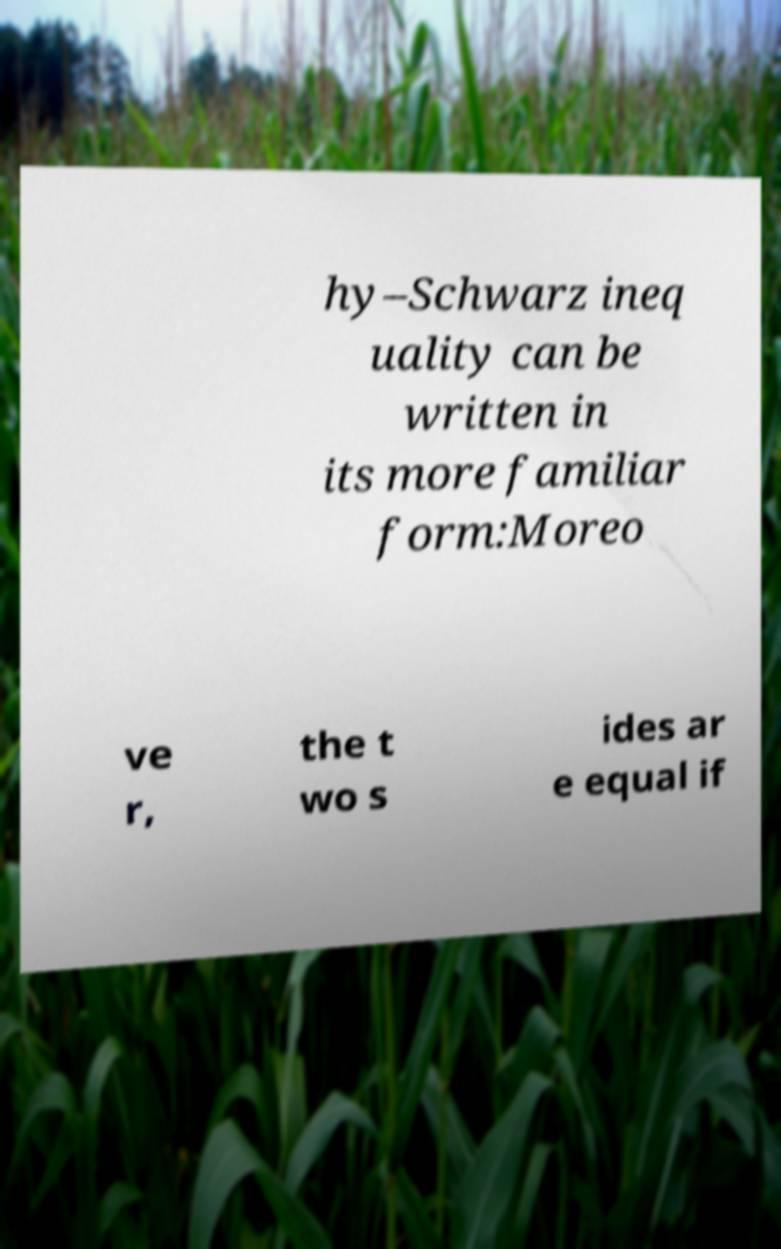I need the written content from this picture converted into text. Can you do that? hy–Schwarz ineq uality can be written in its more familiar form:Moreo ve r, the t wo s ides ar e equal if 